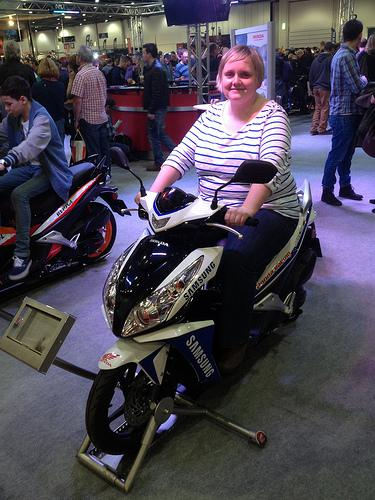Question: what is she sitting on?
Choices:
A. A motorbike.
B. A bicycle.
C. A car hood.
D. A skateboard.
Answer with the letter. Answer: A Question: how many motorbikes are seen?
Choices:
A. 4.
B. 2.
C. 6.
D. 8.
Answer with the letter. Answer: B Question: why is the bike braced?
Choices:
A. So someone can learn to ride.
B. To make it a stationary bike.
C. So it's not stolen.
D. So it will not fall.
Answer with the letter. Answer: D Question: when will she get off?
Choices:
A. After work.
B. After the photo.
C. After her bike ride.
D. After she eats.
Answer with the letter. Answer: B 